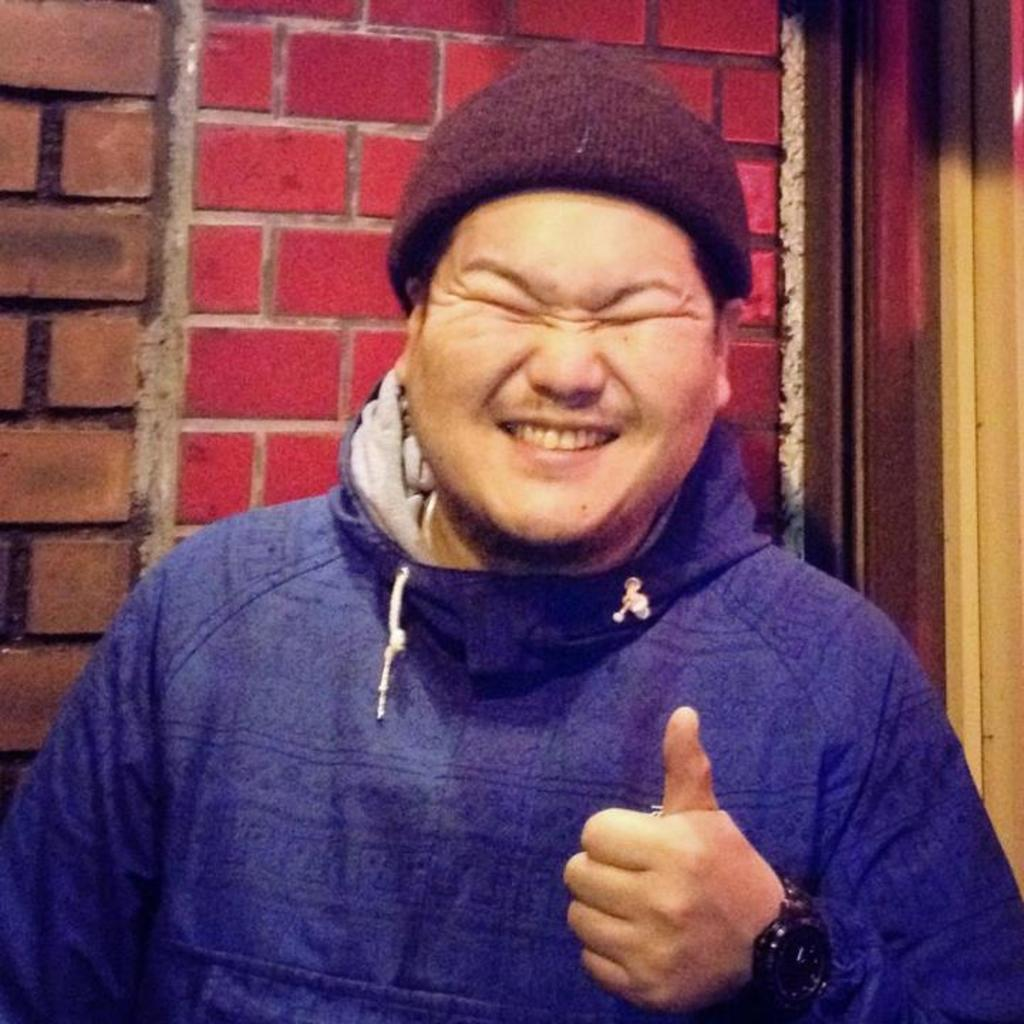Who is present in the image? There is a man in the image. What is the man wearing on his head? The man is wearing a cap. What type of clothing is the man wearing on his upper body? The man is wearing a hoodie. What can be seen in the background of the image? There is a wall in the background of the image. What architectural feature is visible on the right side of the image? There appears to be a door on the right side of the image. How many bones can be seen in the image? There are no bones visible in the image; it features a man wearing a cap and hoodie, with a wall and door in the background. 